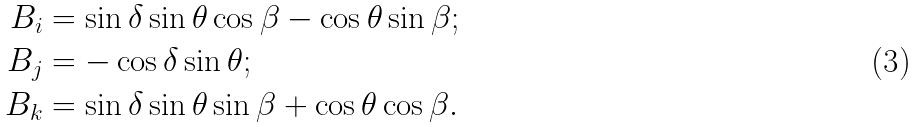<formula> <loc_0><loc_0><loc_500><loc_500>B _ { i } & = \sin \delta \sin \theta \cos \beta - \cos \theta \sin \beta ; \\ B _ { j } & = - \cos \delta \sin \theta ; \\ B _ { k } & = \sin \delta \sin \theta \sin \beta + \cos \theta \cos \beta .</formula> 